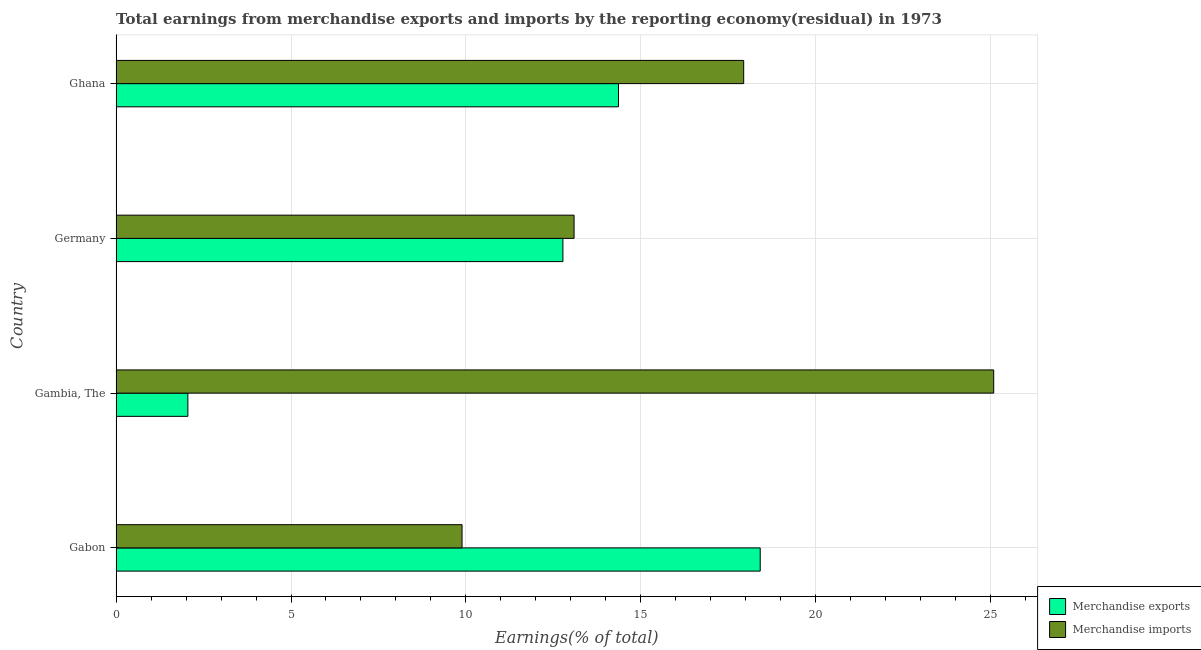Are the number of bars per tick equal to the number of legend labels?
Make the answer very short. Yes. Are the number of bars on each tick of the Y-axis equal?
Provide a succinct answer. Yes. How many bars are there on the 2nd tick from the bottom?
Provide a succinct answer. 2. What is the label of the 4th group of bars from the top?
Your answer should be compact. Gabon. In how many cases, is the number of bars for a given country not equal to the number of legend labels?
Offer a terse response. 0. What is the earnings from merchandise exports in Gambia, The?
Your answer should be very brief. 2.05. Across all countries, what is the maximum earnings from merchandise exports?
Ensure brevity in your answer.  18.42. Across all countries, what is the minimum earnings from merchandise imports?
Your answer should be very brief. 9.89. In which country was the earnings from merchandise exports maximum?
Give a very brief answer. Gabon. In which country was the earnings from merchandise exports minimum?
Provide a succinct answer. Gambia, The. What is the total earnings from merchandise exports in the graph?
Your response must be concise. 47.61. What is the difference between the earnings from merchandise imports in Gabon and that in Germany?
Provide a succinct answer. -3.2. What is the difference between the earnings from merchandise exports in Gambia, The and the earnings from merchandise imports in Germany?
Provide a short and direct response. -11.04. What is the average earnings from merchandise imports per country?
Provide a short and direct response. 16.51. What is the difference between the earnings from merchandise exports and earnings from merchandise imports in Gabon?
Provide a succinct answer. 8.53. In how many countries, is the earnings from merchandise imports greater than 21 %?
Make the answer very short. 1. What is the ratio of the earnings from merchandise imports in Germany to that in Ghana?
Ensure brevity in your answer.  0.73. What is the difference between the highest and the second highest earnings from merchandise imports?
Provide a short and direct response. 7.15. In how many countries, is the earnings from merchandise imports greater than the average earnings from merchandise imports taken over all countries?
Make the answer very short. 2. What does the 1st bar from the top in Gambia, The represents?
Ensure brevity in your answer.  Merchandise imports. What does the 2nd bar from the bottom in Ghana represents?
Provide a succinct answer. Merchandise imports. How many countries are there in the graph?
Offer a terse response. 4. Are the values on the major ticks of X-axis written in scientific E-notation?
Give a very brief answer. No. Where does the legend appear in the graph?
Ensure brevity in your answer.  Bottom right. How many legend labels are there?
Offer a terse response. 2. What is the title of the graph?
Provide a succinct answer. Total earnings from merchandise exports and imports by the reporting economy(residual) in 1973. What is the label or title of the X-axis?
Offer a terse response. Earnings(% of total). What is the label or title of the Y-axis?
Provide a succinct answer. Country. What is the Earnings(% of total) of Merchandise exports in Gabon?
Make the answer very short. 18.42. What is the Earnings(% of total) of Merchandise imports in Gabon?
Provide a short and direct response. 9.89. What is the Earnings(% of total) in Merchandise exports in Gambia, The?
Offer a very short reply. 2.05. What is the Earnings(% of total) in Merchandise imports in Gambia, The?
Ensure brevity in your answer.  25.09. What is the Earnings(% of total) of Merchandise exports in Germany?
Offer a very short reply. 12.78. What is the Earnings(% of total) in Merchandise imports in Germany?
Your response must be concise. 13.09. What is the Earnings(% of total) in Merchandise exports in Ghana?
Offer a terse response. 14.36. What is the Earnings(% of total) of Merchandise imports in Ghana?
Provide a short and direct response. 17.94. Across all countries, what is the maximum Earnings(% of total) of Merchandise exports?
Provide a succinct answer. 18.42. Across all countries, what is the maximum Earnings(% of total) in Merchandise imports?
Provide a succinct answer. 25.09. Across all countries, what is the minimum Earnings(% of total) of Merchandise exports?
Give a very brief answer. 2.05. Across all countries, what is the minimum Earnings(% of total) of Merchandise imports?
Provide a short and direct response. 9.89. What is the total Earnings(% of total) of Merchandise exports in the graph?
Ensure brevity in your answer.  47.61. What is the total Earnings(% of total) in Merchandise imports in the graph?
Your response must be concise. 66.02. What is the difference between the Earnings(% of total) of Merchandise exports in Gabon and that in Gambia, The?
Keep it short and to the point. 16.37. What is the difference between the Earnings(% of total) in Merchandise imports in Gabon and that in Gambia, The?
Provide a short and direct response. -15.2. What is the difference between the Earnings(% of total) in Merchandise exports in Gabon and that in Germany?
Provide a succinct answer. 5.64. What is the difference between the Earnings(% of total) in Merchandise imports in Gabon and that in Germany?
Your answer should be very brief. -3.2. What is the difference between the Earnings(% of total) of Merchandise exports in Gabon and that in Ghana?
Your answer should be very brief. 4.05. What is the difference between the Earnings(% of total) of Merchandise imports in Gabon and that in Ghana?
Offer a terse response. -8.05. What is the difference between the Earnings(% of total) of Merchandise exports in Gambia, The and that in Germany?
Offer a terse response. -10.72. What is the difference between the Earnings(% of total) in Merchandise imports in Gambia, The and that in Germany?
Give a very brief answer. 12. What is the difference between the Earnings(% of total) of Merchandise exports in Gambia, The and that in Ghana?
Your answer should be compact. -12.31. What is the difference between the Earnings(% of total) of Merchandise imports in Gambia, The and that in Ghana?
Provide a short and direct response. 7.15. What is the difference between the Earnings(% of total) in Merchandise exports in Germany and that in Ghana?
Your response must be concise. -1.59. What is the difference between the Earnings(% of total) in Merchandise imports in Germany and that in Ghana?
Offer a very short reply. -4.85. What is the difference between the Earnings(% of total) of Merchandise exports in Gabon and the Earnings(% of total) of Merchandise imports in Gambia, The?
Provide a short and direct response. -6.68. What is the difference between the Earnings(% of total) of Merchandise exports in Gabon and the Earnings(% of total) of Merchandise imports in Germany?
Offer a very short reply. 5.32. What is the difference between the Earnings(% of total) of Merchandise exports in Gabon and the Earnings(% of total) of Merchandise imports in Ghana?
Ensure brevity in your answer.  0.47. What is the difference between the Earnings(% of total) of Merchandise exports in Gambia, The and the Earnings(% of total) of Merchandise imports in Germany?
Offer a very short reply. -11.04. What is the difference between the Earnings(% of total) of Merchandise exports in Gambia, The and the Earnings(% of total) of Merchandise imports in Ghana?
Your answer should be very brief. -15.89. What is the difference between the Earnings(% of total) in Merchandise exports in Germany and the Earnings(% of total) in Merchandise imports in Ghana?
Keep it short and to the point. -5.17. What is the average Earnings(% of total) of Merchandise exports per country?
Your response must be concise. 11.9. What is the average Earnings(% of total) in Merchandise imports per country?
Your answer should be compact. 16.51. What is the difference between the Earnings(% of total) of Merchandise exports and Earnings(% of total) of Merchandise imports in Gabon?
Your answer should be compact. 8.53. What is the difference between the Earnings(% of total) of Merchandise exports and Earnings(% of total) of Merchandise imports in Gambia, The?
Provide a short and direct response. -23.04. What is the difference between the Earnings(% of total) in Merchandise exports and Earnings(% of total) in Merchandise imports in Germany?
Provide a short and direct response. -0.32. What is the difference between the Earnings(% of total) in Merchandise exports and Earnings(% of total) in Merchandise imports in Ghana?
Keep it short and to the point. -3.58. What is the ratio of the Earnings(% of total) of Merchandise exports in Gabon to that in Gambia, The?
Your response must be concise. 8.98. What is the ratio of the Earnings(% of total) of Merchandise imports in Gabon to that in Gambia, The?
Provide a succinct answer. 0.39. What is the ratio of the Earnings(% of total) in Merchandise exports in Gabon to that in Germany?
Your response must be concise. 1.44. What is the ratio of the Earnings(% of total) of Merchandise imports in Gabon to that in Germany?
Provide a succinct answer. 0.76. What is the ratio of the Earnings(% of total) in Merchandise exports in Gabon to that in Ghana?
Make the answer very short. 1.28. What is the ratio of the Earnings(% of total) of Merchandise imports in Gabon to that in Ghana?
Your answer should be very brief. 0.55. What is the ratio of the Earnings(% of total) in Merchandise exports in Gambia, The to that in Germany?
Provide a short and direct response. 0.16. What is the ratio of the Earnings(% of total) of Merchandise imports in Gambia, The to that in Germany?
Provide a short and direct response. 1.92. What is the ratio of the Earnings(% of total) of Merchandise exports in Gambia, The to that in Ghana?
Offer a very short reply. 0.14. What is the ratio of the Earnings(% of total) of Merchandise imports in Gambia, The to that in Ghana?
Provide a succinct answer. 1.4. What is the ratio of the Earnings(% of total) in Merchandise exports in Germany to that in Ghana?
Give a very brief answer. 0.89. What is the ratio of the Earnings(% of total) in Merchandise imports in Germany to that in Ghana?
Keep it short and to the point. 0.73. What is the difference between the highest and the second highest Earnings(% of total) in Merchandise exports?
Keep it short and to the point. 4.05. What is the difference between the highest and the second highest Earnings(% of total) in Merchandise imports?
Offer a very short reply. 7.15. What is the difference between the highest and the lowest Earnings(% of total) in Merchandise exports?
Offer a terse response. 16.37. What is the difference between the highest and the lowest Earnings(% of total) in Merchandise imports?
Make the answer very short. 15.2. 